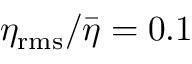<formula> <loc_0><loc_0><loc_500><loc_500>\eta _ { r m s } / \bar { \eta } = 0 . 1</formula> 